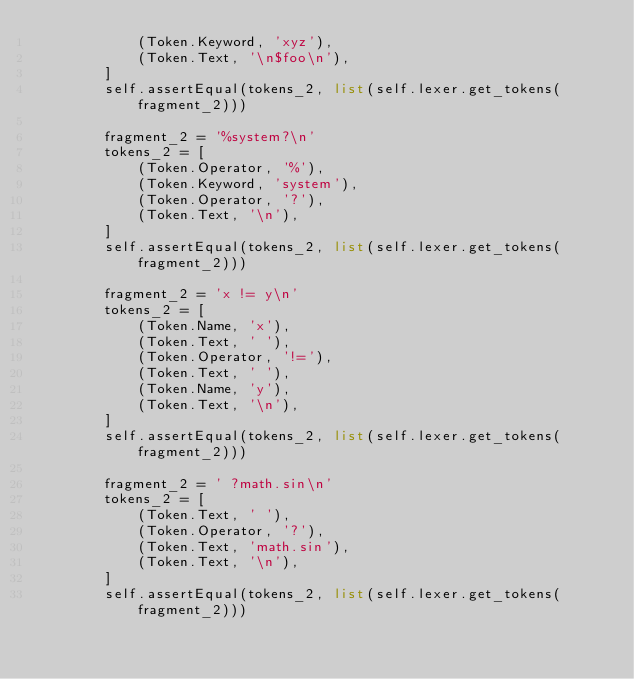Convert code to text. <code><loc_0><loc_0><loc_500><loc_500><_Python_>            (Token.Keyword, 'xyz'),
            (Token.Text, '\n$foo\n'),
        ]
        self.assertEqual(tokens_2, list(self.lexer.get_tokens(fragment_2)))

        fragment_2 = '%system?\n'
        tokens_2 = [
            (Token.Operator, '%'),
            (Token.Keyword, 'system'),
            (Token.Operator, '?'),
            (Token.Text, '\n'),
        ]
        self.assertEqual(tokens_2, list(self.lexer.get_tokens(fragment_2)))

        fragment_2 = 'x != y\n'
        tokens_2 = [
            (Token.Name, 'x'),
            (Token.Text, ' '),
            (Token.Operator, '!='),
            (Token.Text, ' '),
            (Token.Name, 'y'),
            (Token.Text, '\n'),
        ]
        self.assertEqual(tokens_2, list(self.lexer.get_tokens(fragment_2)))

        fragment_2 = ' ?math.sin\n'
        tokens_2 = [
            (Token.Text, ' '),
            (Token.Operator, '?'),
            (Token.Text, 'math.sin'),
            (Token.Text, '\n'),
        ]
        self.assertEqual(tokens_2, list(self.lexer.get_tokens(fragment_2)))
</code> 